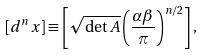<formula> <loc_0><loc_0><loc_500><loc_500>[ d ^ { n } x ] \equiv \left [ \sqrt { \det A } \left ( \frac { \alpha \beta } { \pi } \right ) ^ { n / 2 } \right ] ,</formula> 